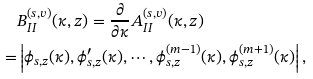Convert formula to latex. <formula><loc_0><loc_0><loc_500><loc_500>& B _ { I I } ^ { ( s , v ) } ( \kappa , z ) = \frac { \partial } { \partial \kappa } A _ { I I } ^ { ( s , v ) } ( \kappa , z ) \\ = & \left | \phi _ { s , z } ( \kappa ) , \phi _ { s , z } ^ { \prime } ( \kappa ) , \cdots , \phi _ { s , z } ^ { ( m - 1 ) } ( \kappa ) , \phi _ { s , z } ^ { ( m + 1 ) } ( \kappa ) \right | ,</formula> 